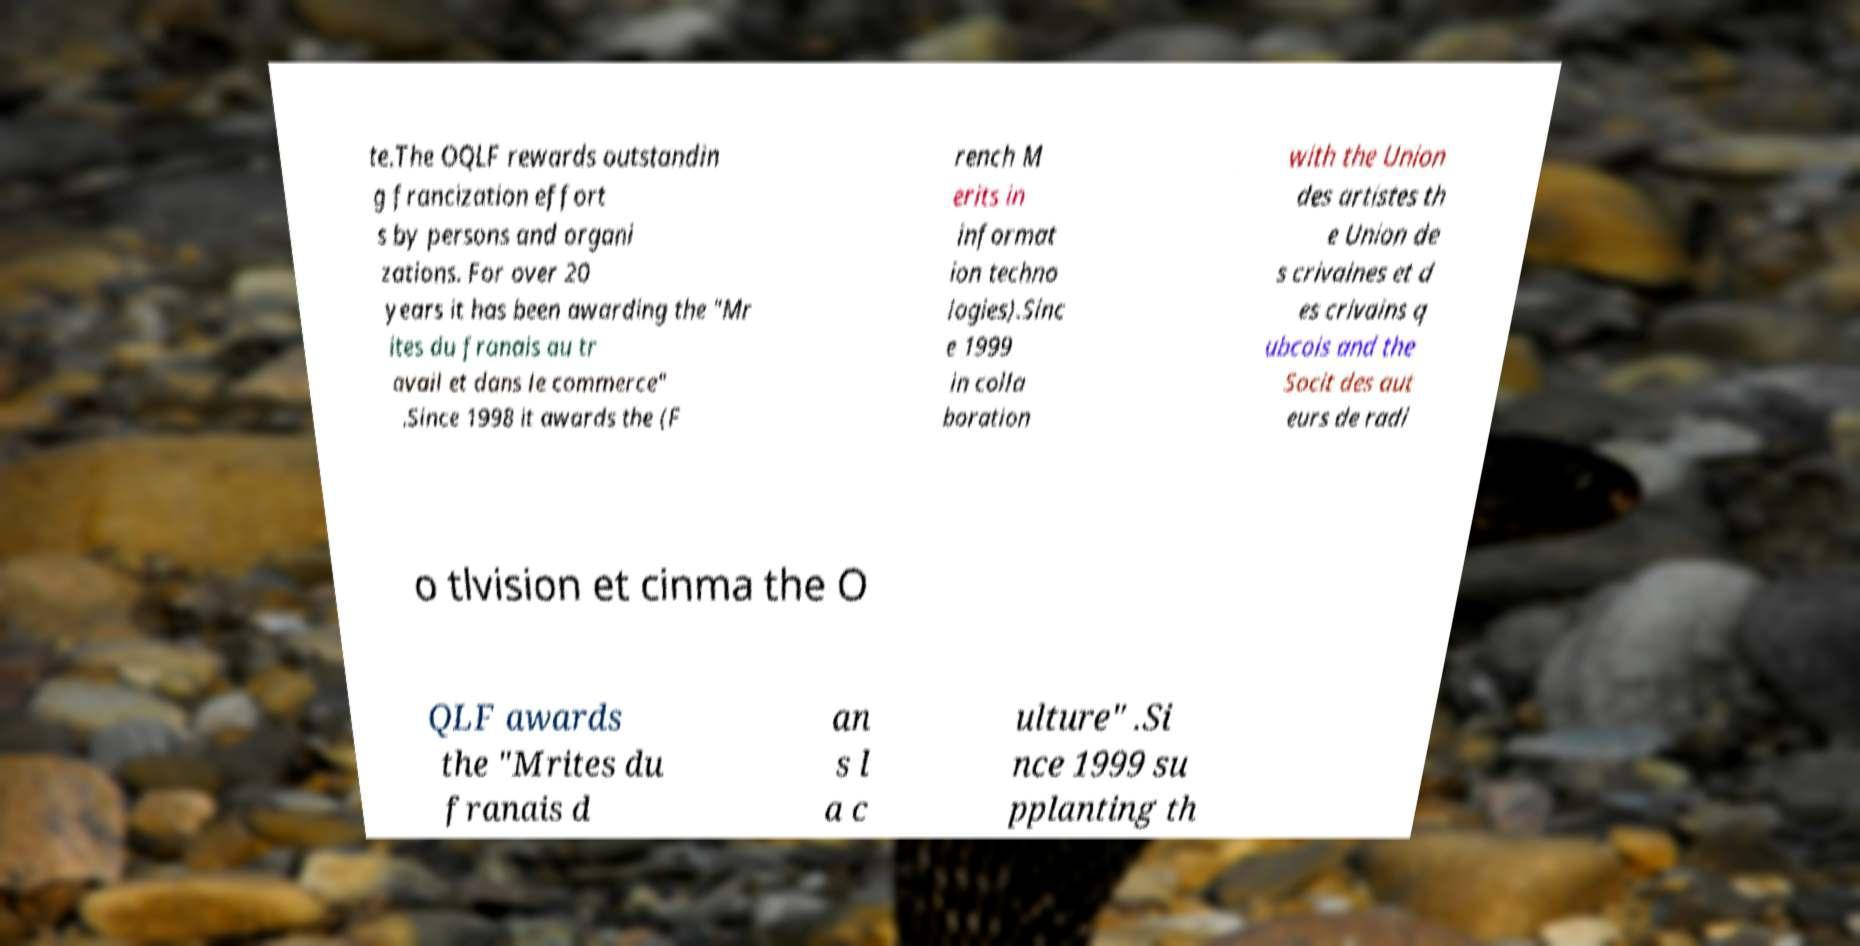For documentation purposes, I need the text within this image transcribed. Could you provide that? te.The OQLF rewards outstandin g francization effort s by persons and organi zations. For over 20 years it has been awarding the "Mr ites du franais au tr avail et dans le commerce" .Since 1998 it awards the (F rench M erits in informat ion techno logies).Sinc e 1999 in colla boration with the Union des artistes th e Union de s crivaines et d es crivains q ubcois and the Socit des aut eurs de radi o tlvision et cinma the O QLF awards the "Mrites du franais d an s l a c ulture" .Si nce 1999 su pplanting th 